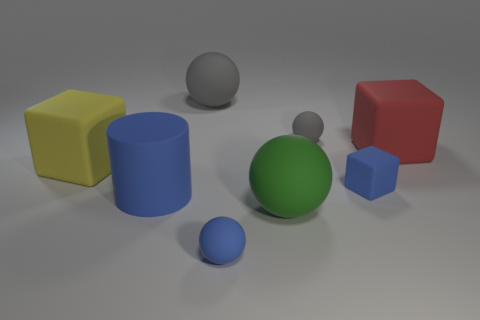Add 2 big green spheres. How many objects exist? 10 Subtract all blocks. How many objects are left? 5 Add 2 large red cylinders. How many large red cylinders exist? 2 Subtract 1 red blocks. How many objects are left? 7 Subtract all blocks. Subtract all large cubes. How many objects are left? 3 Add 1 tiny balls. How many tiny balls are left? 3 